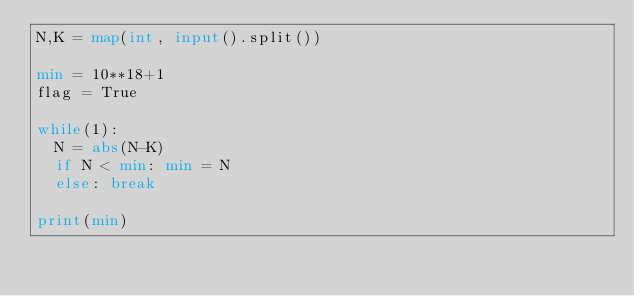<code> <loc_0><loc_0><loc_500><loc_500><_Python_>N,K = map(int, input().split())

min = 10**18+1
flag = True

while(1):
  N = abs(N-K)
  if N < min: min = N
  else: break
    
print(min)</code> 